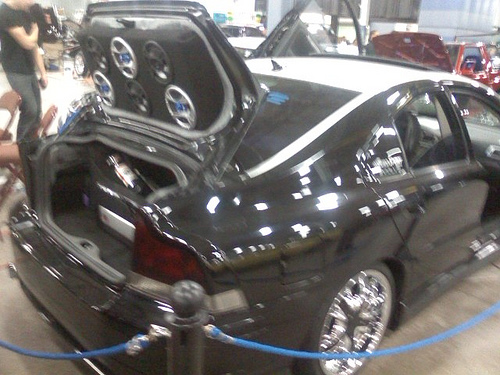<image>
Is the car on the road? No. The car is not positioned on the road. They may be near each other, but the car is not supported by or resting on top of the road. 